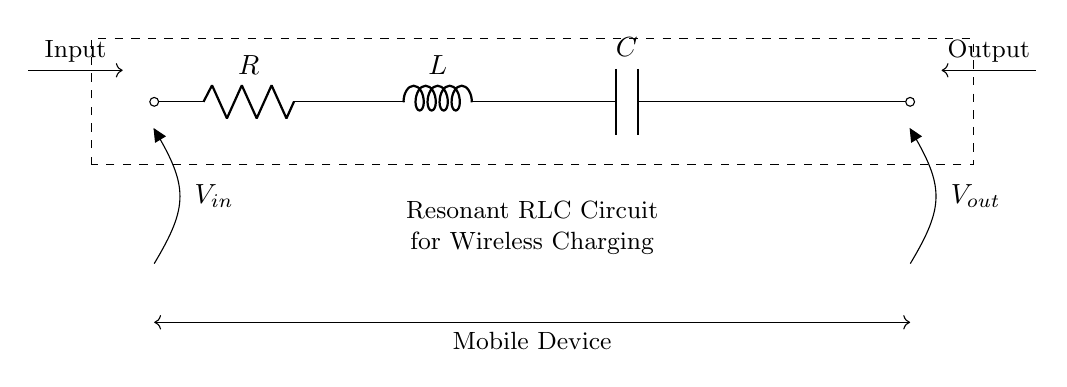What are the components present in the circuit? The circuit contains a resistor, an inductor, and a capacitor, which are essential for forming a resonant RLC circuit.
Answer: Resistor, Inductor, Capacitor What is the role of the inductance in this circuit? The inductance helps store energy in a magnetic field and interacts with the capacitance to set the resonant frequency of the circuit, allowing efficient energy transfer for wireless charging.
Answer: Energy storage What is the current flow direction in the circuit? The current flows from the input side through the resistor, then to the inductor, and finally to the capacitor, before returning to the output.
Answer: From input to output What is the resonant frequency determined by in this circuit? The resonant frequency is determined by the values of the resistor, inductor, and capacitor and is calculated using the formula that relates these components.
Answer: R, L, C values What happens to the circuit when the resistance increases? Increasing the resistance decreases the overall current flowing in the circuit and affects the quality factor, leading to less efficient energy transfer.
Answer: Decreased current What is the function of the output in this wireless charging circuit? The output provides a voltage source that powers the mobile device after the circuit processes the input energy through resonance.
Answer: Power mobile device 